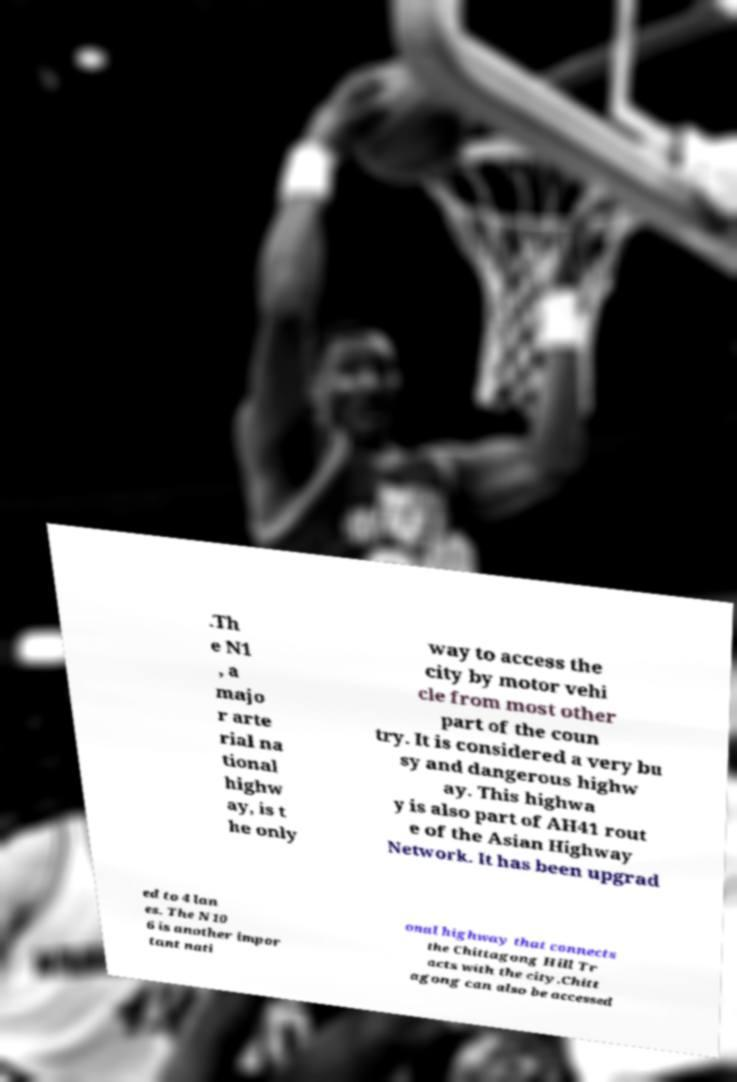For documentation purposes, I need the text within this image transcribed. Could you provide that? .Th e N1 , a majo r arte rial na tional highw ay, is t he only way to access the city by motor vehi cle from most other part of the coun try. It is considered a very bu sy and dangerous highw ay. This highwa y is also part of AH41 rout e of the Asian Highway Network. It has been upgrad ed to 4 lan es. The N10 6 is another impor tant nati onal highway that connects the Chittagong Hill Tr acts with the city.Chitt agong can also be accessed 